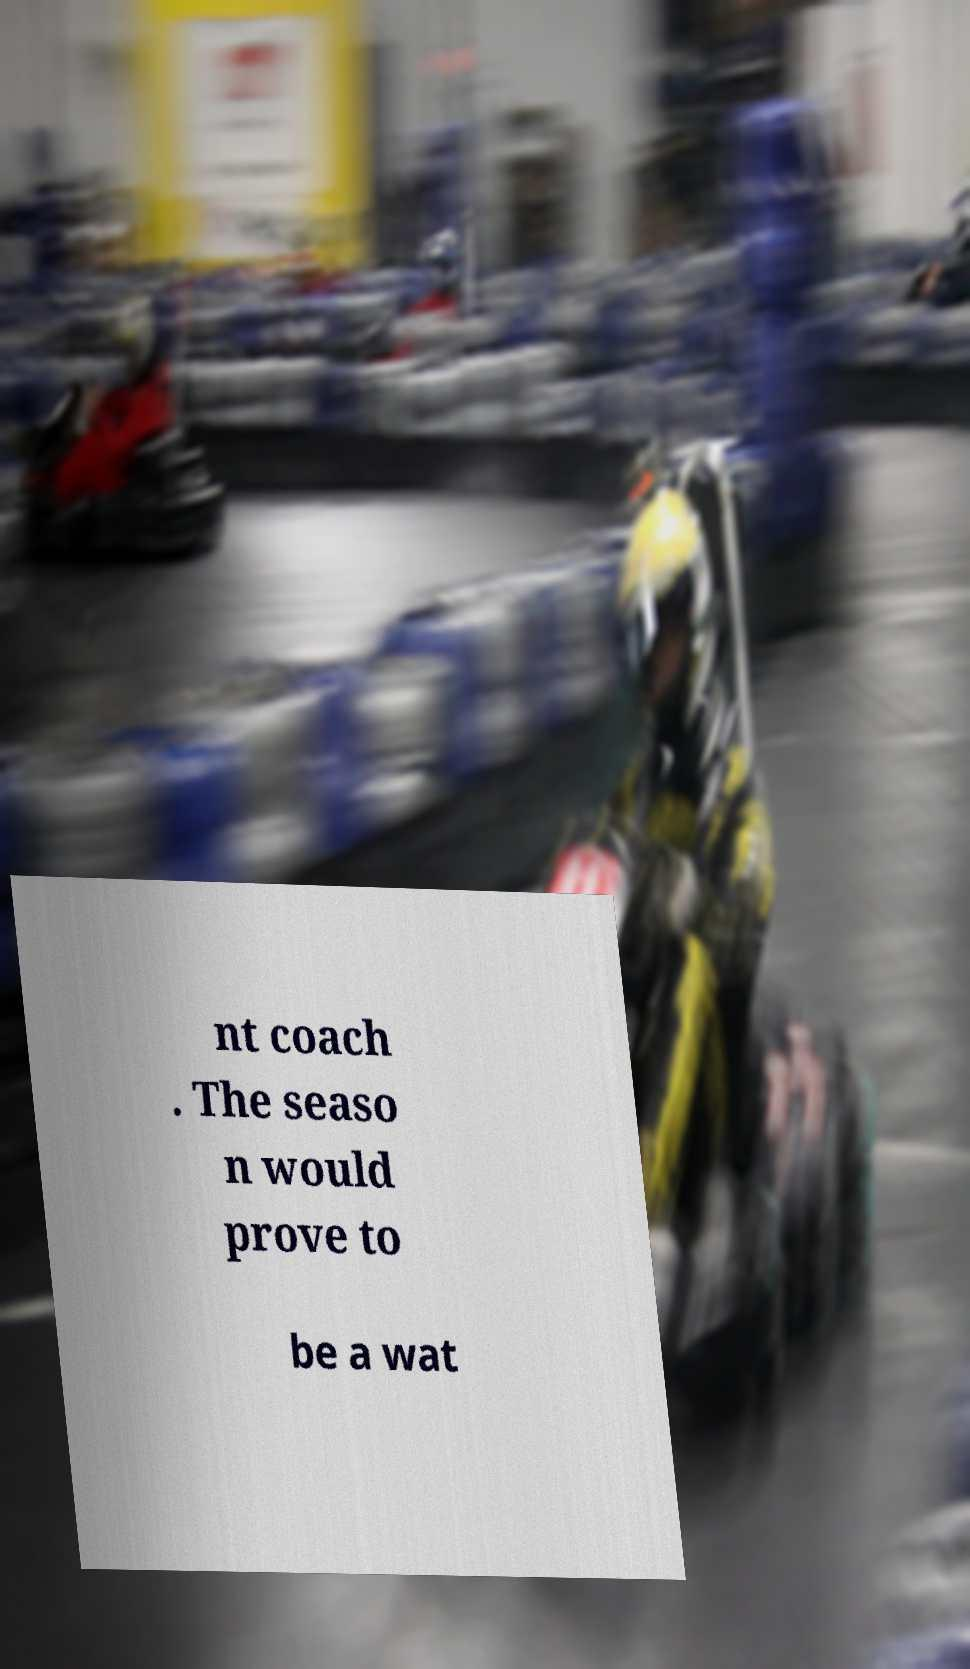Could you extract and type out the text from this image? nt coach . The seaso n would prove to be a wat 